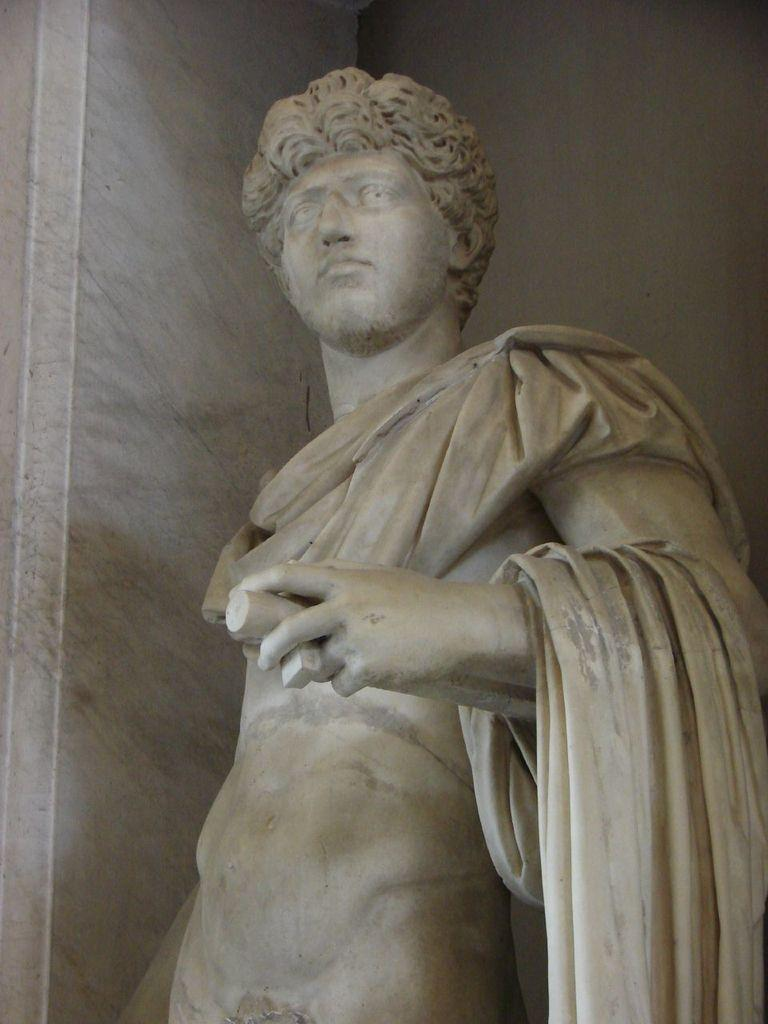What is the main subject in the image? There is a statue in the image. What else can be seen in the image besides the statue? There is a wall in the image. What is the statue's reaction to the disgusting story being told in the image? There is no story being told in the image, and the statue does not have the ability to react to a story. 